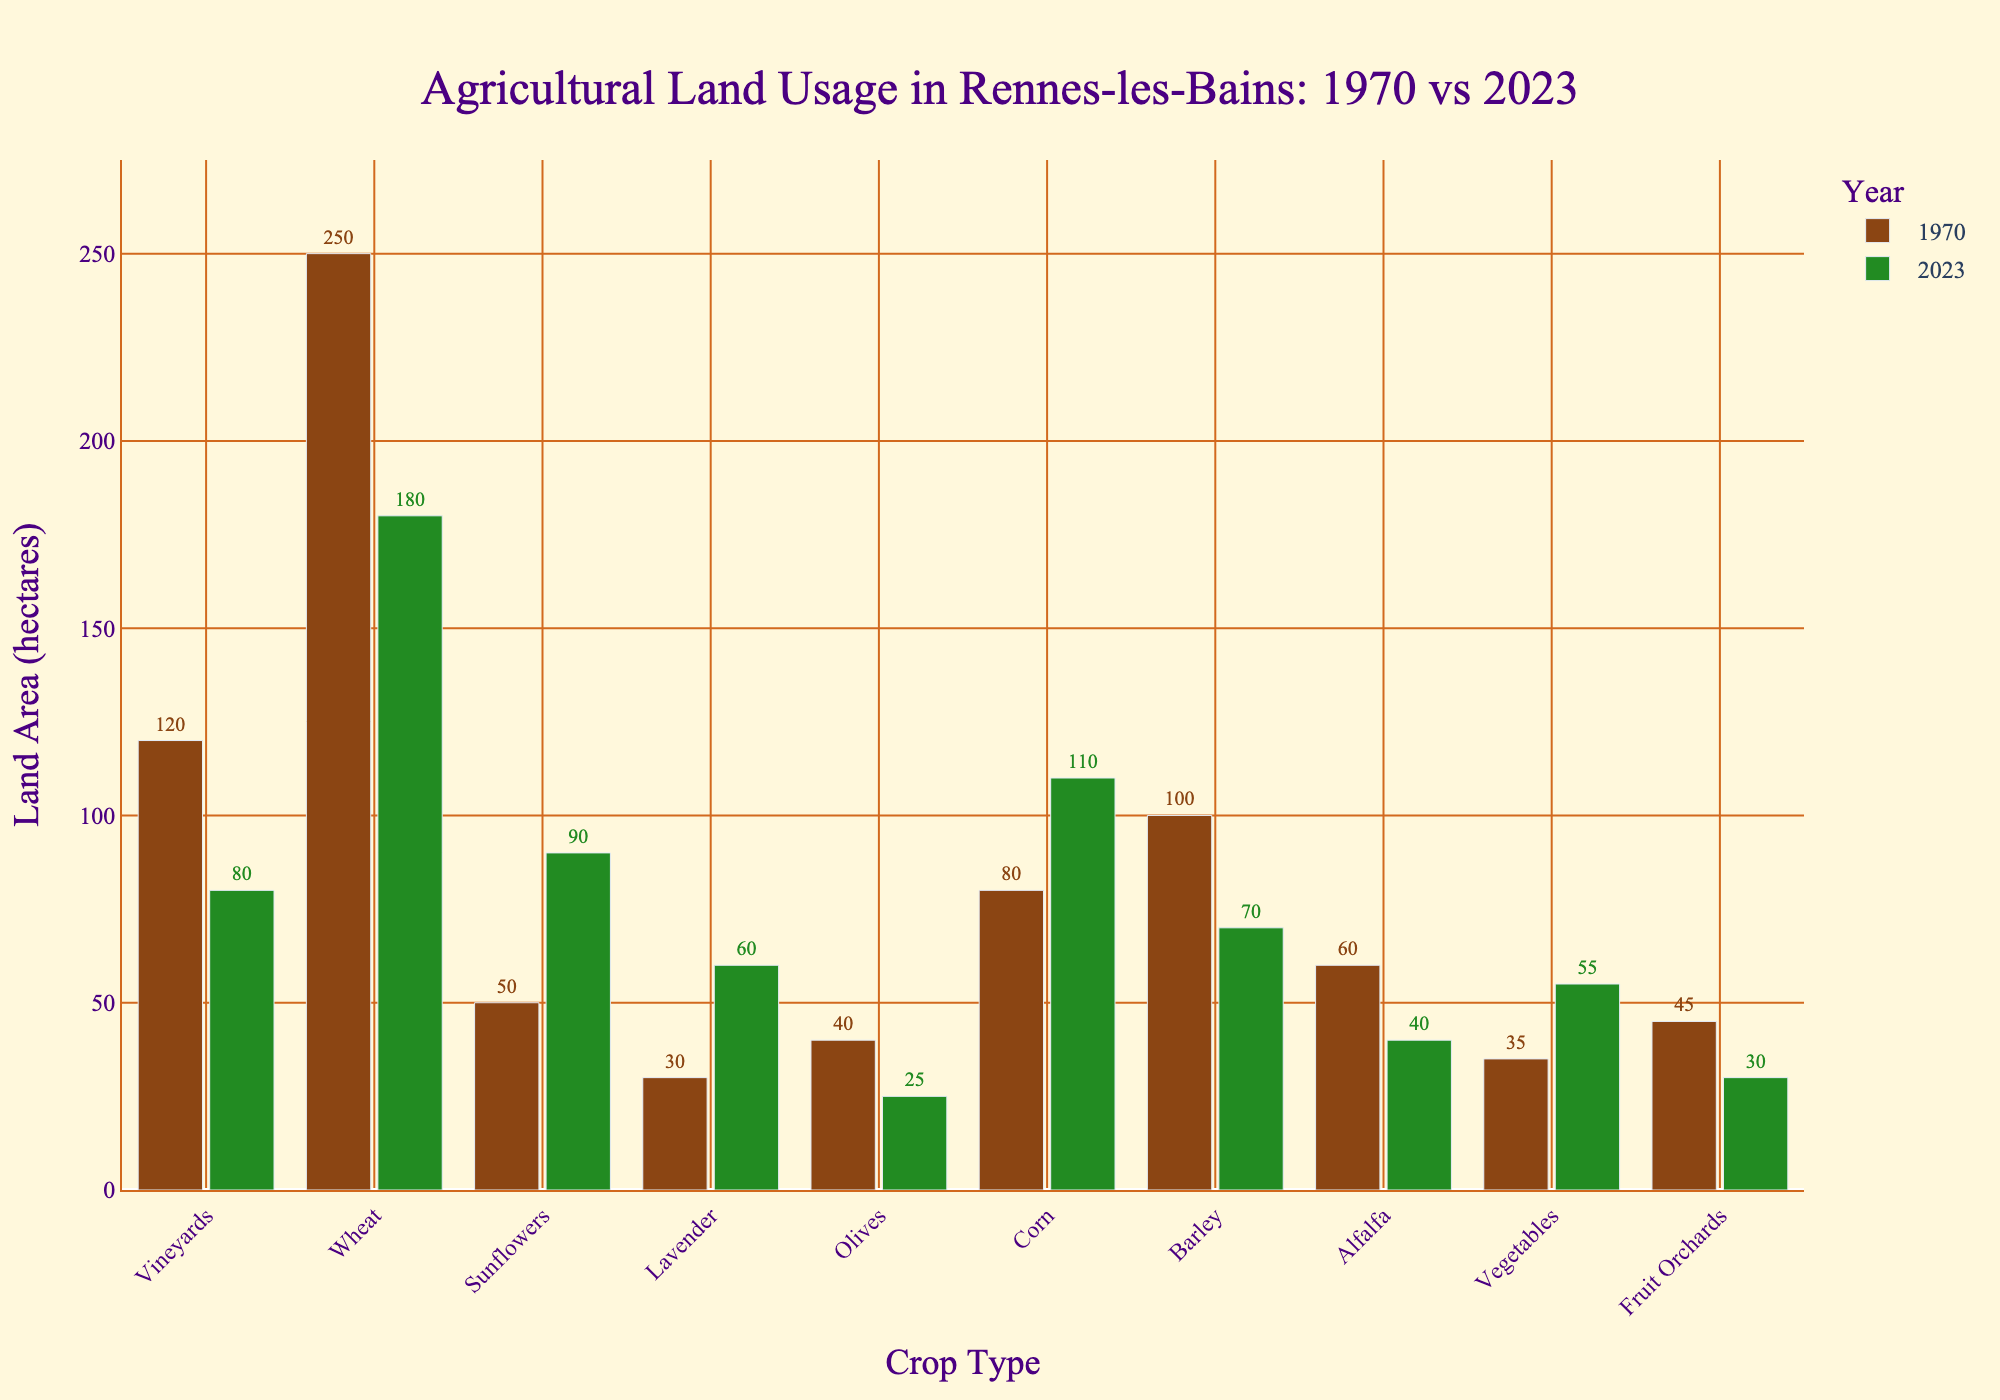Which crop type had the greatest reduction in land usage from 1970 to 2023? The crop type with the greatest reduction in land usage can be found by examining the differences between the 1970 and 2023 bars for each crop type and identifying the largest negative change. The reduction for Vineyards is (120 - 80 = 40), Wheat is (250 - 180 = 70), Olives is (40 - 25 = 15), Barley is (100 - 70 = 30), Alfalfa is (60 - 40 = 20), and Fruit Orchards are (45 - 30 = 15). Wheat shows the greatest reduction with a decrease of 70 hectares.
Answer: Wheat Which crop types show an increase in land usage from 1970 to 2023? To find which crop types have increased in land usage, compare the heights of the 2023 bars to the 1970 bars. The crop types with higher 2023 bars are Sunflowers, Lavender, Corn, and Vegetables.
Answer: Sunflowers, Lavender, Corn, Vegetables What is the total land usage for wheat and olives combined in 2023? To find the total land usage for wheat and olives combined in 2023, simply add the 2023 values for these crop types. Wheat has 180 hectares and Olives have 25 hectares in 2023. The total land usage is (180 + 25).
Answer: 205 hectares Which crop type had the smallest land usage in 1970? By visually examining the heights of the bars for 1970, the shortest bar corresponds to the smallest land usage. Lavender, with 30 hectares, has the smallest usage in 1970.
Answer: Lavender Compare the total agricultural land usage in 1970 with that in 2023. Which year had more agricultural land usage overall? Sum the land usage for all crop types for 1970 and 2023, then compare the totals. For 1970: (120 + 250 + 50 + 30 + 40 + 80 + 100 + 60 + 35 + 45) = 810 hectares. For 2023: (80 + 180 + 90 + 60 + 25 + 110 + 70 + 40 + 55 + 30) = 740 hectares. 1970 had more land usage overall.
Answer: 1970 How much did sunflower land usage change from 1970 to 2023 in percentage? To find the percentage change, use the formula: ((new value - old value) / old value) * 100. Sunflowers had 50 hectares in 1970 and 90 hectares in 2023. The percentage change is ((90 - 50) / 50) * 100 = 80%.
Answer: 80% Between which two crop types is the difference in land usage most striking in 2023? To identify the striking difference, visualize the 2023 bars and look for the largest gap between two heights. Wheat and Olives have the largest difference, with Wheat at 180 hectares and Olives at 25 hectares, a difference of 155 hectares.
Answer: Wheat and Olives What is the average land usage for vineyards, wheat, and corn in 1970? Add the 1970 values for these crop types and then divide by the number of crop types. (120 for Vineyards + 250 for Wheat + 80 for Corn) / 3 = 450 / 3 = 150 hectares.
Answer: 150 hectares 